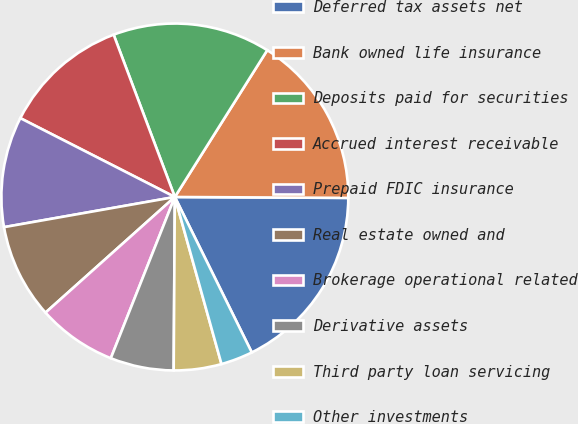Convert chart. <chart><loc_0><loc_0><loc_500><loc_500><pie_chart><fcel>Deferred tax assets net<fcel>Bank owned life insurance<fcel>Deposits paid for securities<fcel>Accrued interest receivable<fcel>Prepaid FDIC insurance<fcel>Real estate owned and<fcel>Brokerage operational related<fcel>Derivative assets<fcel>Third party loan servicing<fcel>Other investments<nl><fcel>17.6%<fcel>16.14%<fcel>14.68%<fcel>11.75%<fcel>10.29%<fcel>8.83%<fcel>7.37%<fcel>5.91%<fcel>4.44%<fcel>2.98%<nl></chart> 